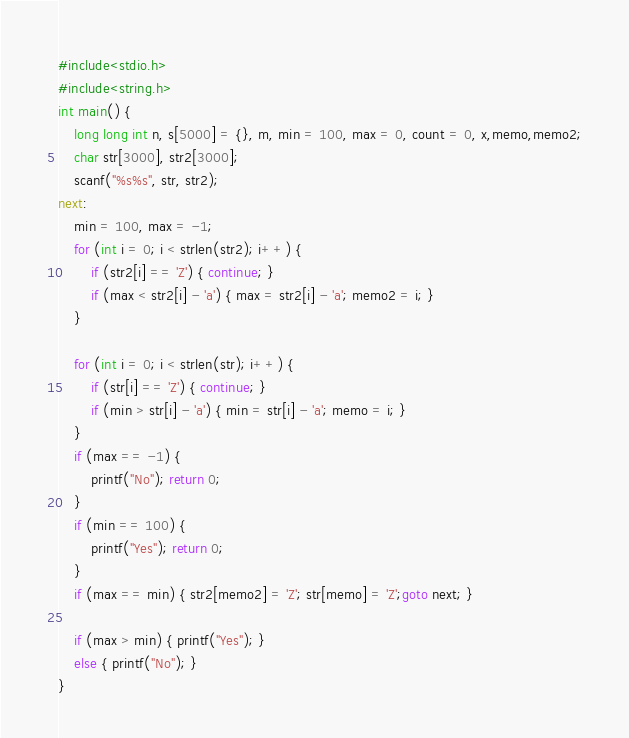<code> <loc_0><loc_0><loc_500><loc_500><_C_>#include<stdio.h>
#include<string.h>
int main() {
	long long int n, s[5000] = {}, m, min = 100, max = 0, count = 0, x,memo,memo2;
	char str[3000], str2[3000];
	scanf("%s%s", str, str2);
next:
	min = 100, max = -1;
	for (int i = 0; i < strlen(str2); i++) {
		if (str2[i] == 'Z') { continue; }
		if (max < str2[i] - 'a') { max = str2[i] - 'a'; memo2 = i; }
	}

	for (int i = 0; i < strlen(str); i++) {
		if (str[i] == 'Z') { continue; }
		if (min > str[i] - 'a') { min = str[i] - 'a'; memo = i; }
	}
	if (max == -1) {
		printf("No"); return 0;
	}
	if (min == 100) {
		printf("Yes"); return 0;
	}
	if (max == min) { str2[memo2] = 'Z'; str[memo] = 'Z';goto next; }
	
	if (max > min) { printf("Yes"); }
	else { printf("No"); }
}</code> 